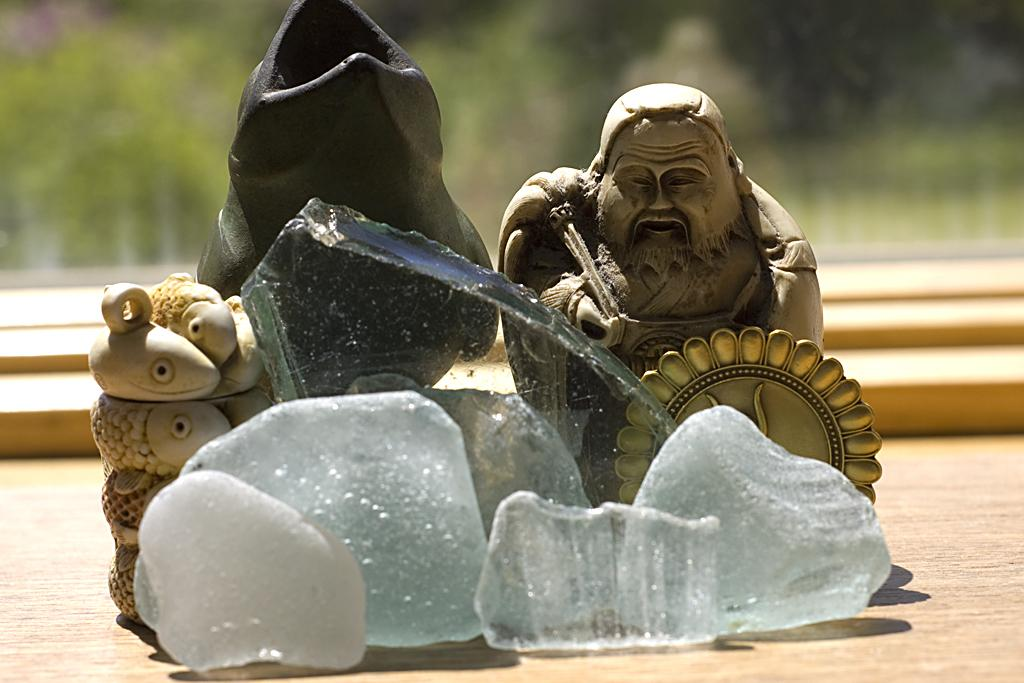What type of objects can be seen in the image? There are statues, stones, and a glass piece in the image. Can you describe the statues in the image? The statues are the main objects in the image, but their specific details are not mentioned in the provided facts. What material are the stones made of? The stones are made of a solid, natural material, but their exact composition is not mentioned in the provided facts. How would you describe the background of the image? The background of the image is blurry, which may affect the visibility of other objects or details. How many frogs can be seen sitting on the parent frog's nest in the image? There are no frogs or nests present in the image; it features statues, stones, and a glass piece. 